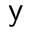<formula> <loc_0><loc_0><loc_500><loc_500>y</formula> 